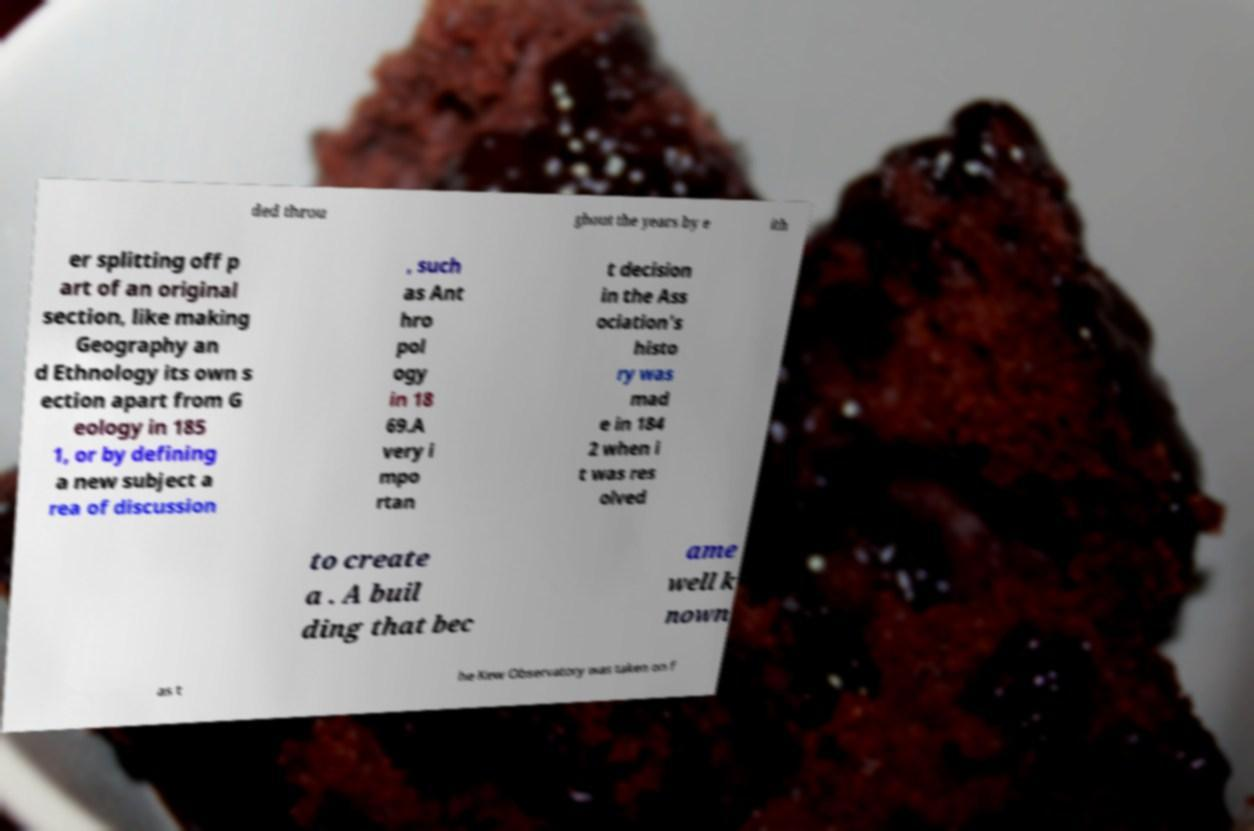Could you assist in decoding the text presented in this image and type it out clearly? ded throu ghout the years by e ith er splitting off p art of an original section, like making Geography an d Ethnology its own s ection apart from G eology in 185 1, or by defining a new subject a rea of discussion , such as Ant hro pol ogy in 18 69.A very i mpo rtan t decision in the Ass ociation's histo ry was mad e in 184 2 when i t was res olved to create a . A buil ding that bec ame well k nown as t he Kew Observatory was taken on f 